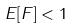<formula> <loc_0><loc_0><loc_500><loc_500>E [ F ] < 1</formula> 